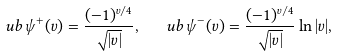Convert formula to latex. <formula><loc_0><loc_0><loc_500><loc_500>\ u b { \psi } ^ { + } ( v ) = \frac { ( - 1 ) ^ { v / 4 } } { \sqrt { | v | } } , \ \ \ u b { \psi } ^ { - } ( v ) = \frac { ( - 1 ) ^ { v / 4 } } { \sqrt { | v | } } \ln | v | ,</formula> 